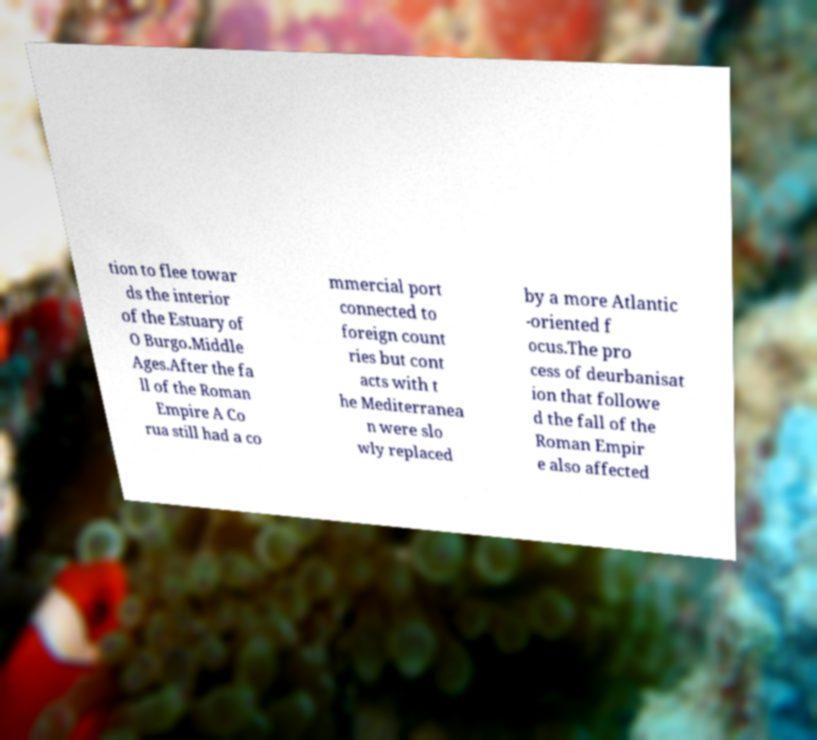Could you assist in decoding the text presented in this image and type it out clearly? tion to flee towar ds the interior of the Estuary of O Burgo.Middle Ages.After the fa ll of the Roman Empire A Co rua still had a co mmercial port connected to foreign count ries but cont acts with t he Mediterranea n were slo wly replaced by a more Atlantic -oriented f ocus.The pro cess of deurbanisat ion that followe d the fall of the Roman Empir e also affected 